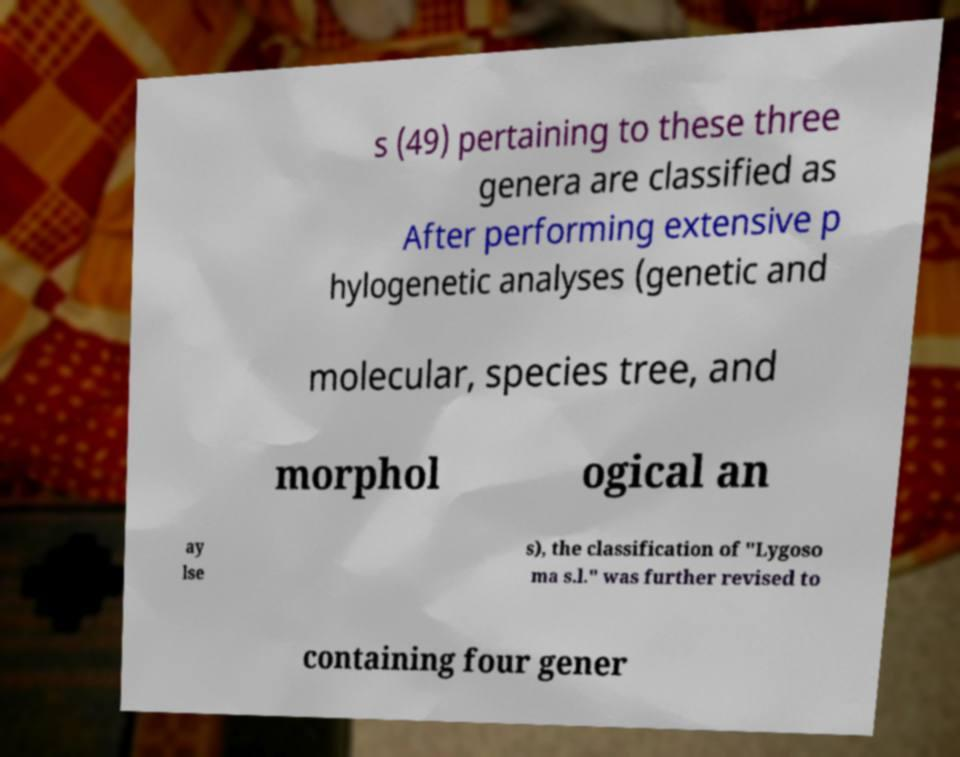Can you read and provide the text displayed in the image?This photo seems to have some interesting text. Can you extract and type it out for me? s (49) pertaining to these three genera are classified as After performing extensive p hylogenetic analyses (genetic and molecular, species tree, and morphol ogical an ay lse s), the classification of "Lygoso ma s.l." was further revised to containing four gener 